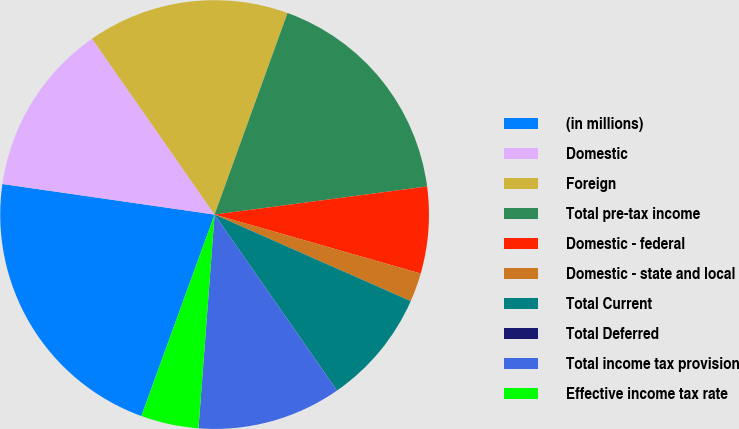Convert chart. <chart><loc_0><loc_0><loc_500><loc_500><pie_chart><fcel>(in millions)<fcel>Domestic<fcel>Foreign<fcel>Total pre-tax income<fcel>Domestic - federal<fcel>Domestic - state and local<fcel>Total Current<fcel>Total Deferred<fcel>Total income tax provision<fcel>Effective income tax rate<nl><fcel>21.73%<fcel>13.04%<fcel>15.21%<fcel>17.38%<fcel>6.53%<fcel>2.18%<fcel>8.7%<fcel>0.01%<fcel>10.87%<fcel>4.35%<nl></chart> 